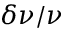Convert formula to latex. <formula><loc_0><loc_0><loc_500><loc_500>\delta \nu / \nu</formula> 